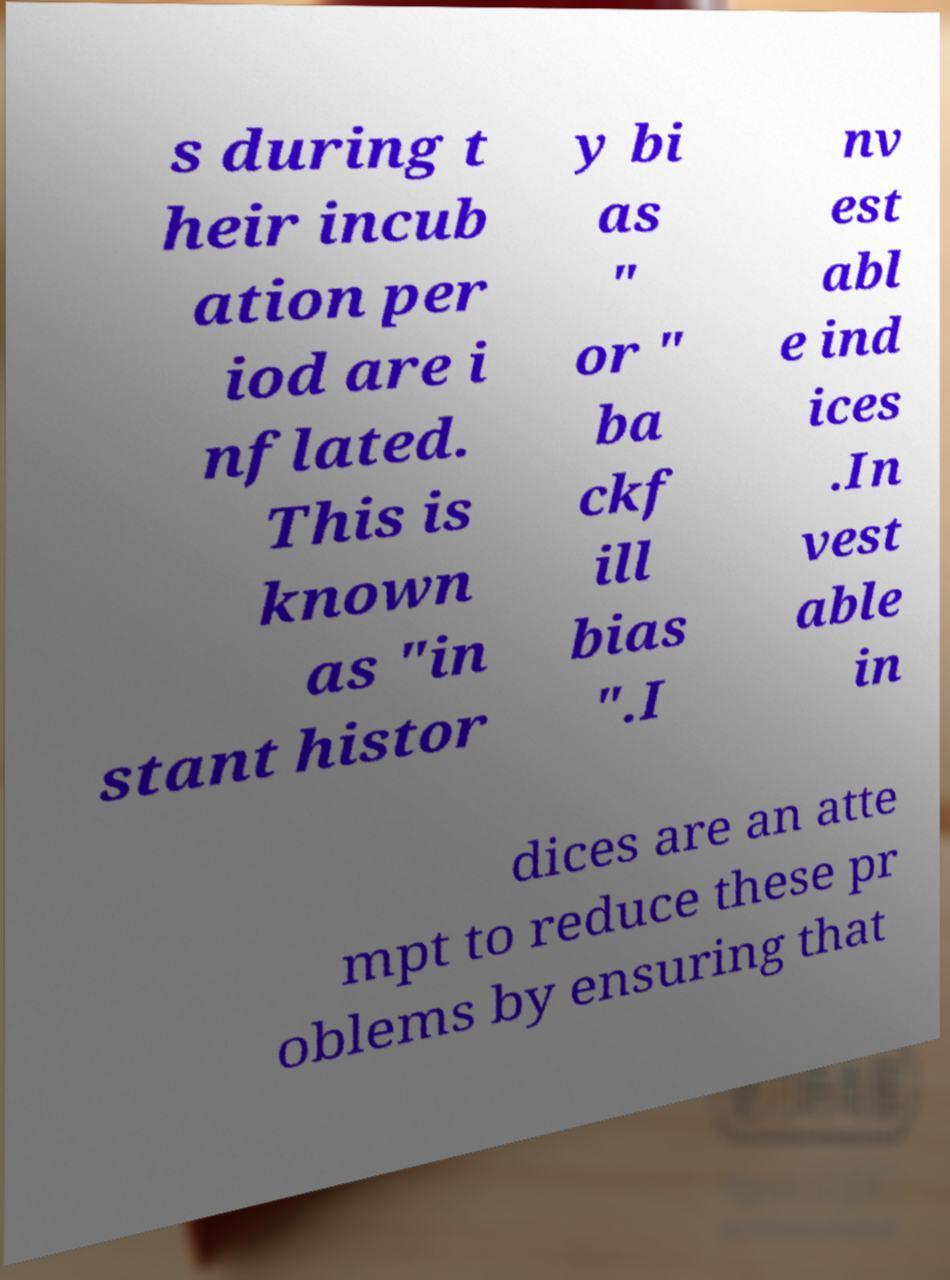What messages or text are displayed in this image? I need them in a readable, typed format. s during t heir incub ation per iod are i nflated. This is known as "in stant histor y bi as " or " ba ckf ill bias ".I nv est abl e ind ices .In vest able in dices are an atte mpt to reduce these pr oblems by ensuring that 